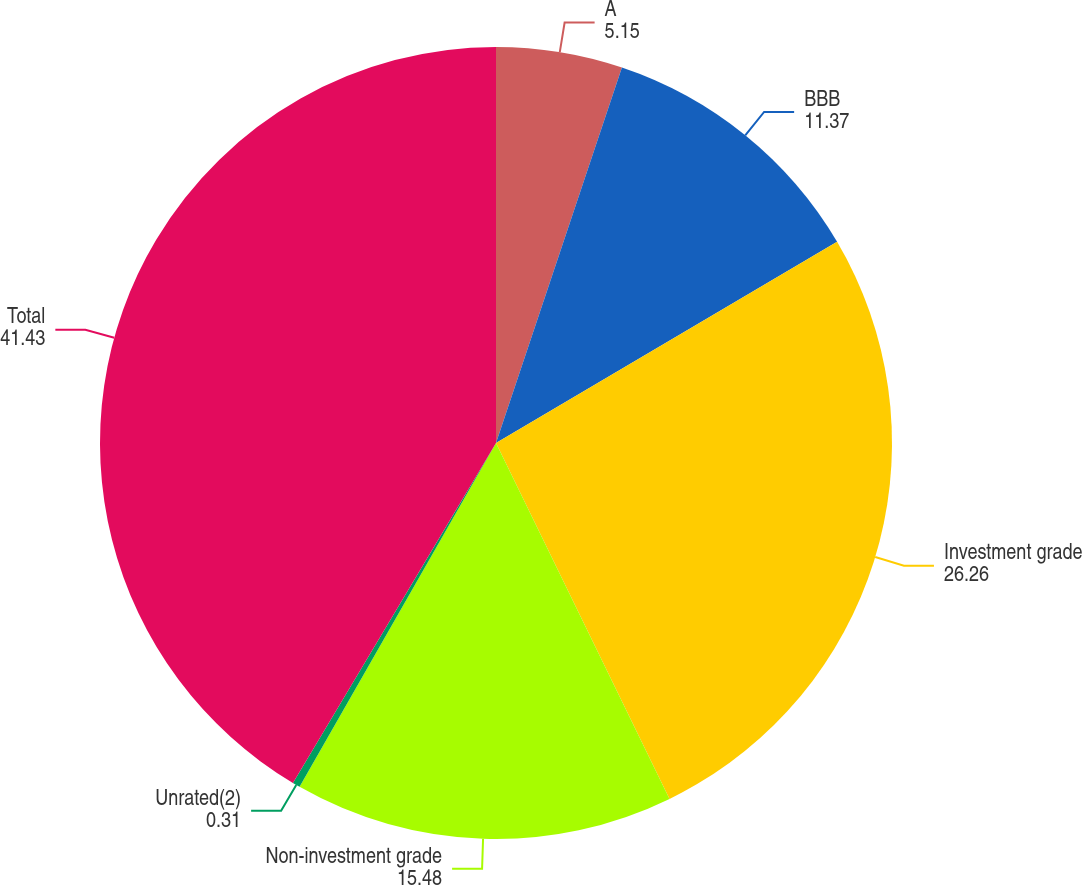<chart> <loc_0><loc_0><loc_500><loc_500><pie_chart><fcel>A<fcel>BBB<fcel>Investment grade<fcel>Non-investment grade<fcel>Unrated(2)<fcel>Total<nl><fcel>5.15%<fcel>11.37%<fcel>26.26%<fcel>15.48%<fcel>0.31%<fcel>41.43%<nl></chart> 